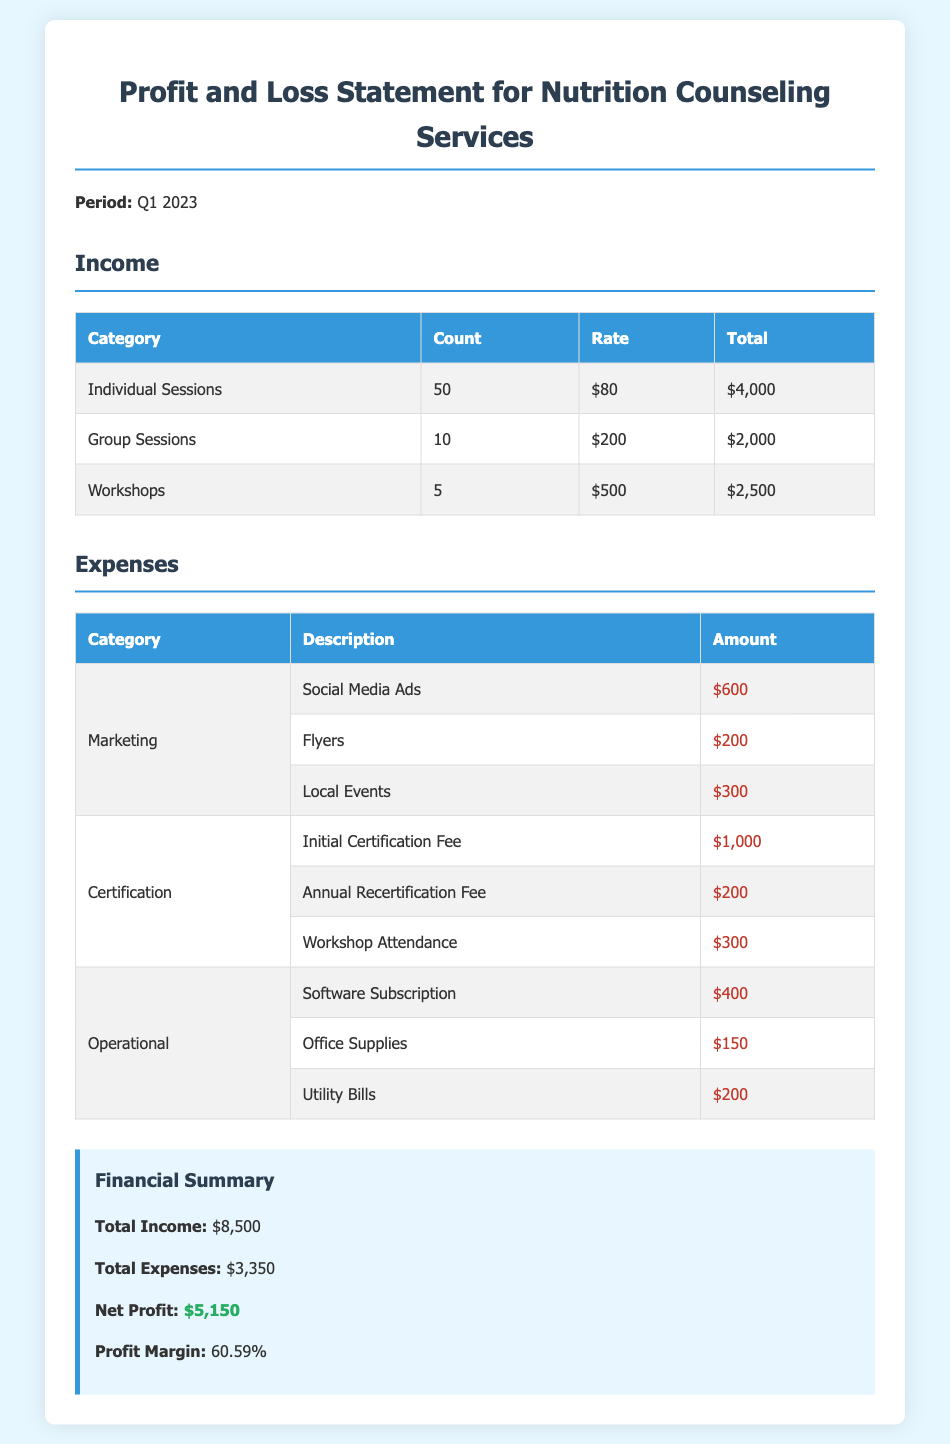What is the total income? The total income is calculated by adding the totals from individual sessions, group sessions, and workshops: $4,000 + $2,000 + $2,500 = $8,500.
Answer: $8,500 What is the total expense for marketing? The total expense for marketing includes social media ads, flyers, and local events: $600 + $200 + $300 = $1,100.
Answer: $1,100 How many individual sessions were conducted? This number is indicated in the income section under individual sessions, which is 50.
Answer: 50 What is the net profit for Q1 2023? The net profit is the difference between total income and total expenses: $8,500 - $3,350 = $5,150.
Answer: $5,150 What is the annual recertification fee? The annual recertification fee is listed under the certification expenses as $200.
Answer: $200 What is the profit margin percentage? The profit margin percentage is provided in the summary and is 60.59%.
Answer: 60.59% What was the amount spent on office supplies? The amount spent on office supplies is specified as $150 in the operational expenses section.
Answer: $150 What were the total expenses for certification? The total expenses for certification include the initial fee, annual recertification fee, and workshop attendance fee: $1,000 + $200 + $300 = $1,500.
Answer: $1,500 What is the rate per group session? The rate per group session is stated in the income section as $200.
Answer: $200 